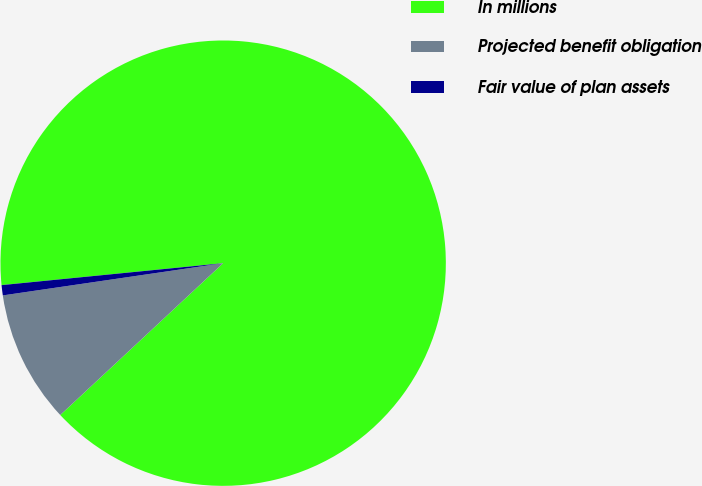Convert chart. <chart><loc_0><loc_0><loc_500><loc_500><pie_chart><fcel>In millions<fcel>Projected benefit obligation<fcel>Fair value of plan assets<nl><fcel>89.63%<fcel>9.63%<fcel>0.74%<nl></chart> 